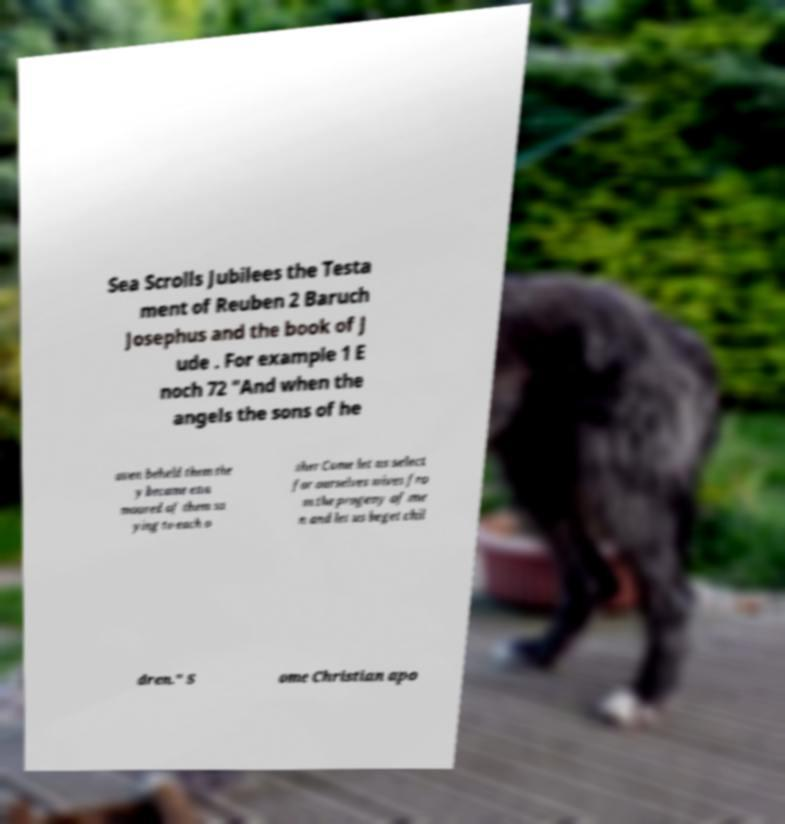Please read and relay the text visible in this image. What does it say? Sea Scrolls Jubilees the Testa ment of Reuben 2 Baruch Josephus and the book of J ude . For example 1 E noch 72 "And when the angels the sons of he aven beheld them the y became ena moured of them sa ying to each o ther Come let us select for ourselves wives fro m the progeny of me n and let us beget chil dren." S ome Christian apo 